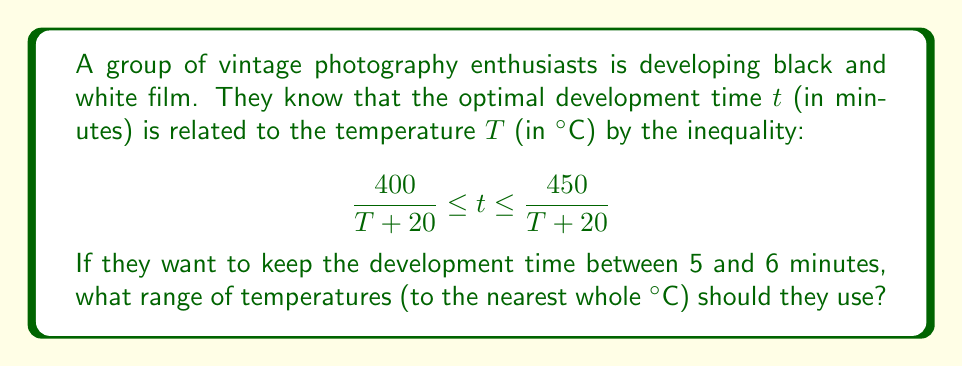Can you solve this math problem? Let's approach this step-by-step:

1) We have two inequalities to work with:
   $t \geq \frac{400}{T+20}$ and $t \leq \frac{450}{T+20}$

2) We also know that $5 \leq t \leq 6$

3) Let's start with the lower bound. We want:
   $5 \leq \frac{400}{T+20}$

4) Multiply both sides by $(T+20)$:
   $5(T+20) \leq 400$

5) Expand:
   $5T + 100 \leq 400$

6) Subtract 100 from both sides:
   $5T \leq 300$

7) Divide by 5:
   $T \leq 60$

8) Now for the upper bound. We want:
   $6 \geq \frac{450}{T+20}$

9) Multiply both sides by $(T+20)$:
   $6(T+20) \geq 450$

10) Expand:
    $6T + 120 \geq 450$

11) Subtract 120 from both sides:
    $6T \geq 330$

12) Divide by 6:
    $T \geq 55$

13) Combining the results from steps 7 and 12:
    $55 \leq T \leq 60$

14) Rounding to the nearest whole °C:
    $55°C \leq T \leq 60°C$
Answer: $55°C \leq T \leq 60°C$ 